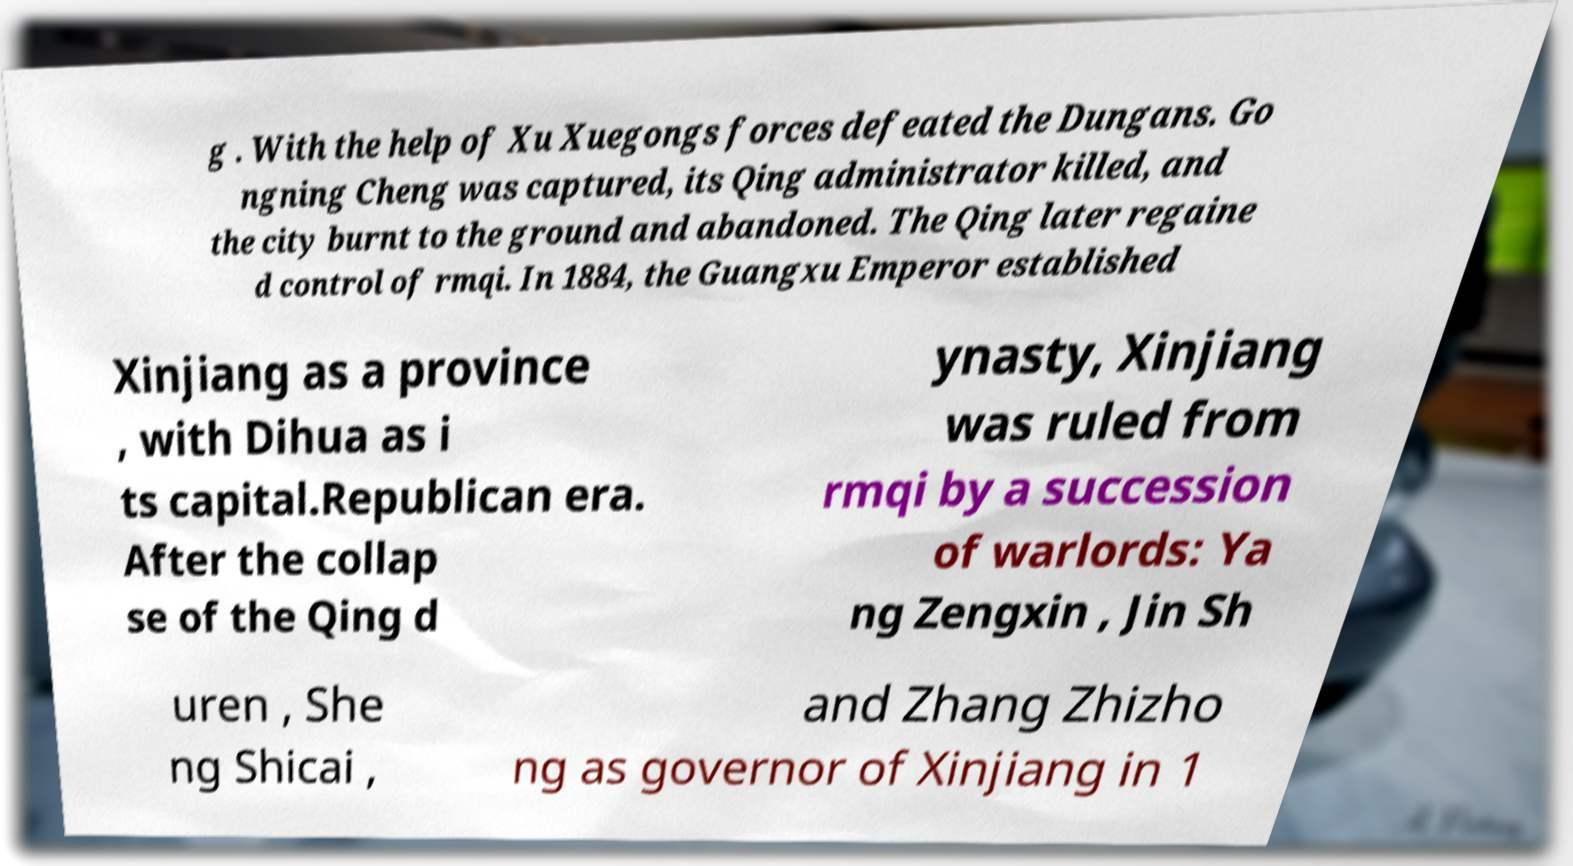What messages or text are displayed in this image? I need them in a readable, typed format. g . With the help of Xu Xuegongs forces defeated the Dungans. Go ngning Cheng was captured, its Qing administrator killed, and the city burnt to the ground and abandoned. The Qing later regaine d control of rmqi. In 1884, the Guangxu Emperor established Xinjiang as a province , with Dihua as i ts capital.Republican era. After the collap se of the Qing d ynasty, Xinjiang was ruled from rmqi by a succession of warlords: Ya ng Zengxin , Jin Sh uren , She ng Shicai , and Zhang Zhizho ng as governor of Xinjiang in 1 